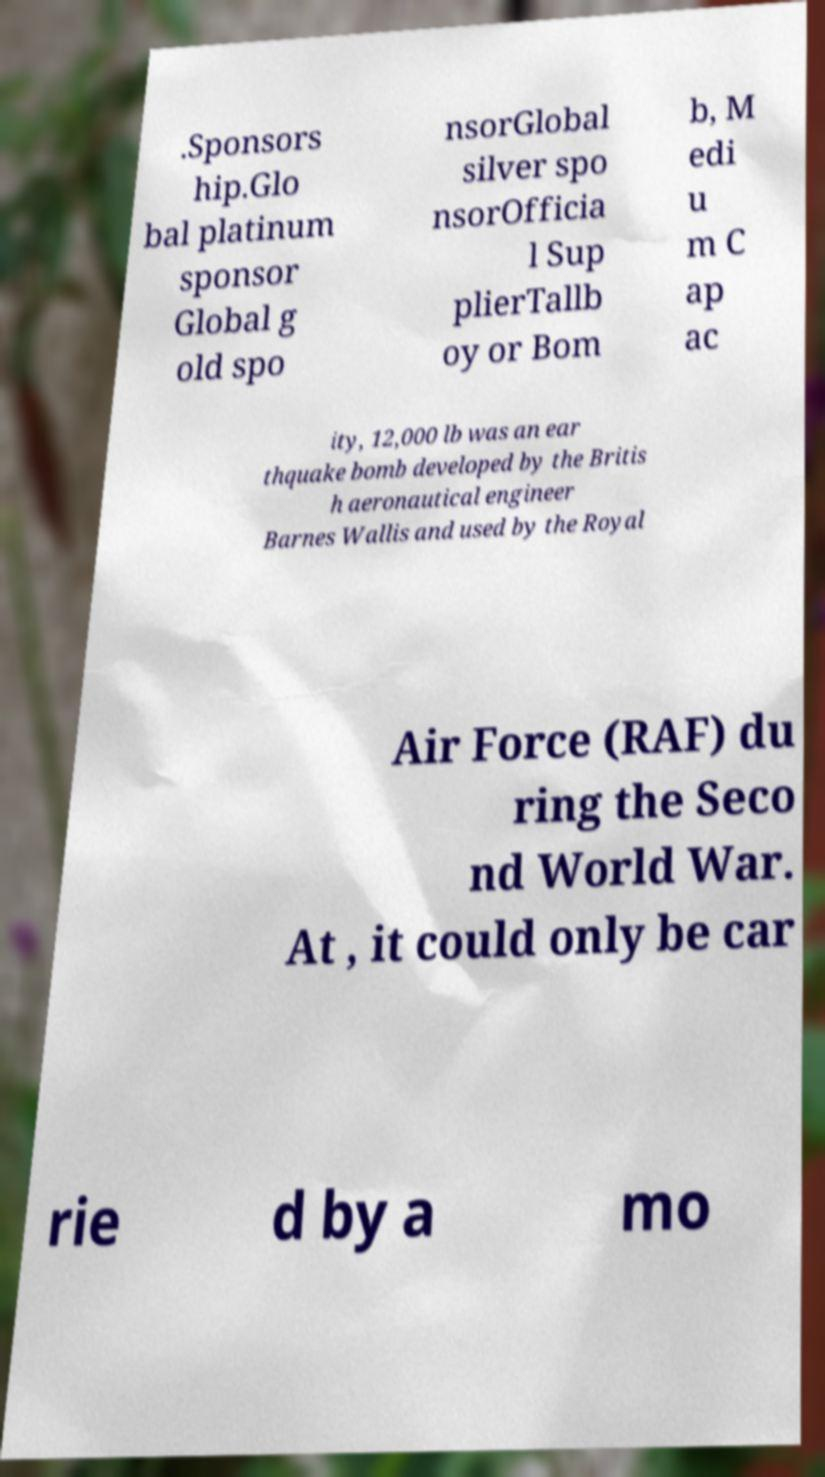Could you assist in decoding the text presented in this image and type it out clearly? .Sponsors hip.Glo bal platinum sponsor Global g old spo nsorGlobal silver spo nsorOfficia l Sup plierTallb oy or Bom b, M edi u m C ap ac ity, 12,000 lb was an ear thquake bomb developed by the Britis h aeronautical engineer Barnes Wallis and used by the Royal Air Force (RAF) du ring the Seco nd World War. At , it could only be car rie d by a mo 